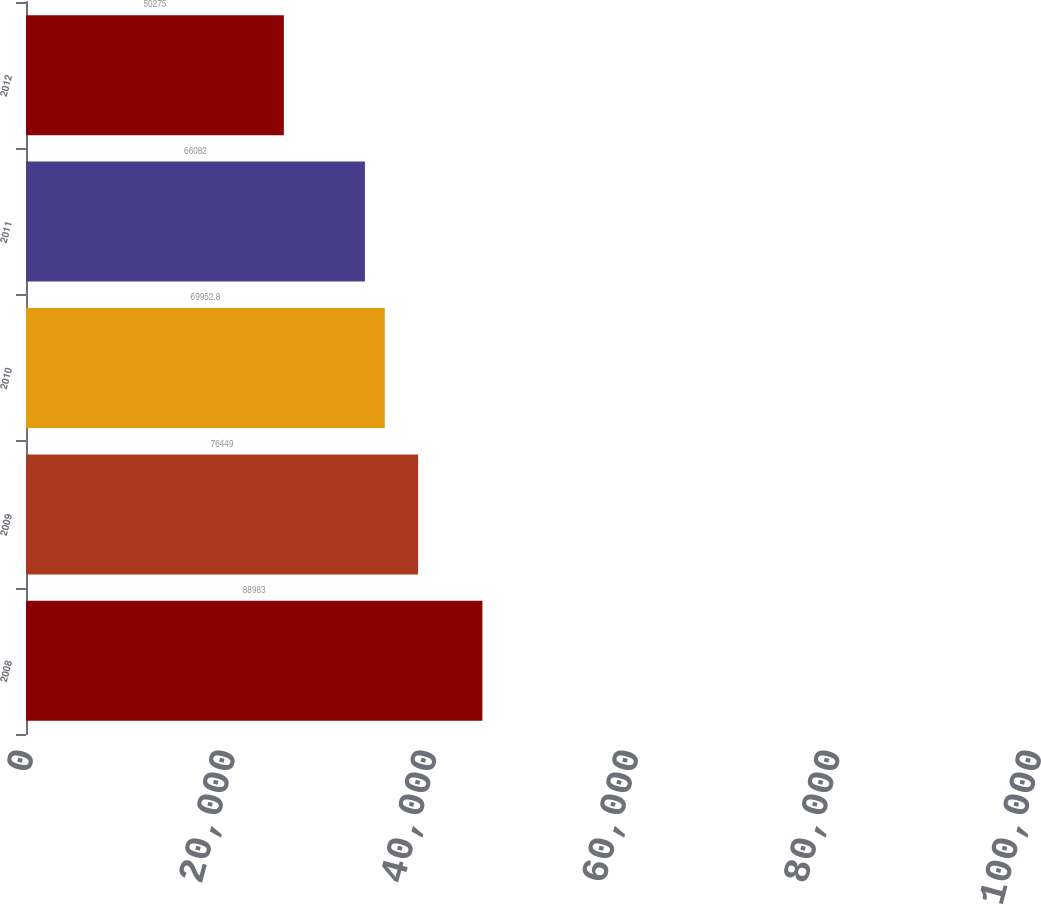<chart> <loc_0><loc_0><loc_500><loc_500><bar_chart><fcel>2008<fcel>2009<fcel>2010<fcel>2011<fcel>2012<nl><fcel>88983<fcel>76449<fcel>69952.8<fcel>66082<fcel>50275<nl></chart> 